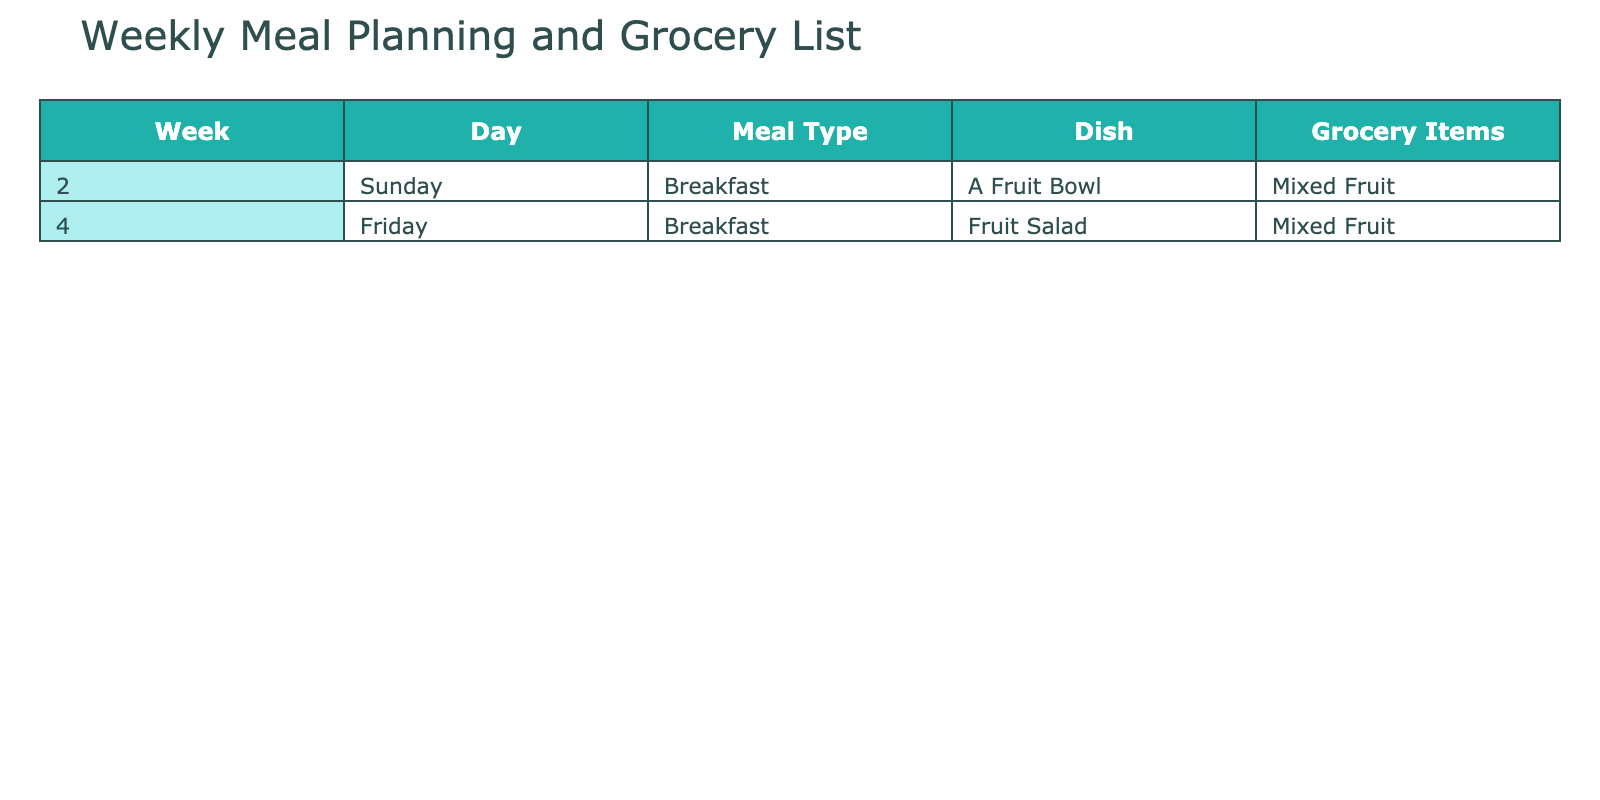What day did we plan to have a Fruit Bowl for breakfast? The table shows that a Fruit Bowl is planned for breakfast on Sunday of week 2.
Answer: Sunday How many different meal types are listed in the table? The table includes two meal types: Breakfast and there are no other types mentioned. Therefore, the total is just 1 type.
Answer: 1 On which day is Fruit Salad scheduled for breakfast? According to the table, Fruit Salad is scheduled for breakfast on Friday of week 4.
Answer: Friday Is Mixed Fruit a grocery item for both planned dishes? The table indicates that Mixed Fruit is listed as a grocery item for both the Fruit Bowl and Fruit Salad dishes, confirming this.
Answer: Yes Which week has a plan for a Fruit Bowl? The table specifies that the Fruit Bowl is planned in week 2, so that is the answer.
Answer: Week 2 What is the total number of dishes planned across the two weeks? There are two dishes listed in the table: a Fruit Bowl and a Fruit Salad, making a total of 2 dishes.
Answer: 2 If we consider only the planned meals for breakfast, are there any weeks without a breakfast plan? The table indicates breakfast plans are present in week 2 and week 4. Thus, all weeks mentioned have a breakfast plan, making the answer No.
Answer: No What is the difference in the weeks when the Fruit Bowl and Fruit Salad are scheduled? The Fruit Bowl is scheduled in week 2, and the Fruit Salad is scheduled in week 4. The difference between week 4 and week 2 is 2 weeks.
Answer: 2 weeks List the grocery items needed for the planned meals according to the table. The grocery items required for both planned meals are Mixed Fruit, which is the only item listed for both dishes.
Answer: Mixed Fruit How many days are accounted for in this table concerning meal planning? The displayed data shows meal plans for two different days: Sunday of week 2 and Friday of week 4, which totals to 2 days.
Answer: 2 days 